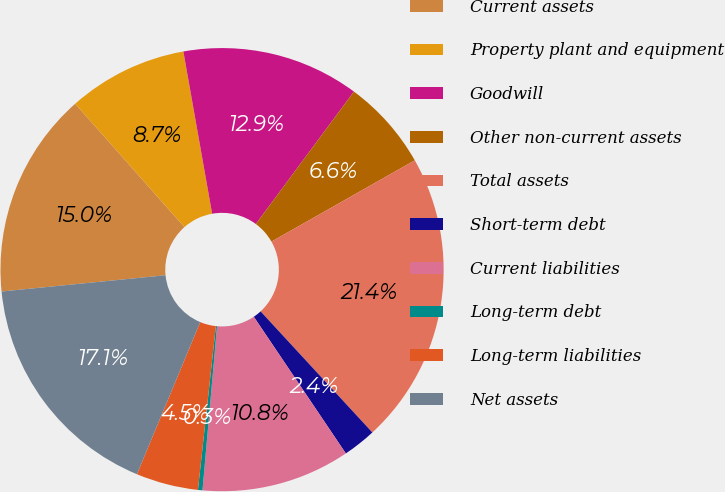Convert chart to OTSL. <chart><loc_0><loc_0><loc_500><loc_500><pie_chart><fcel>Current assets<fcel>Property plant and equipment<fcel>Goodwill<fcel>Other non-current assets<fcel>Total assets<fcel>Short-term debt<fcel>Current liabilities<fcel>Long-term debt<fcel>Long-term liabilities<fcel>Net assets<nl><fcel>15.04%<fcel>8.74%<fcel>12.94%<fcel>6.64%<fcel>21.35%<fcel>2.43%<fcel>10.84%<fcel>0.33%<fcel>4.54%<fcel>17.15%<nl></chart> 